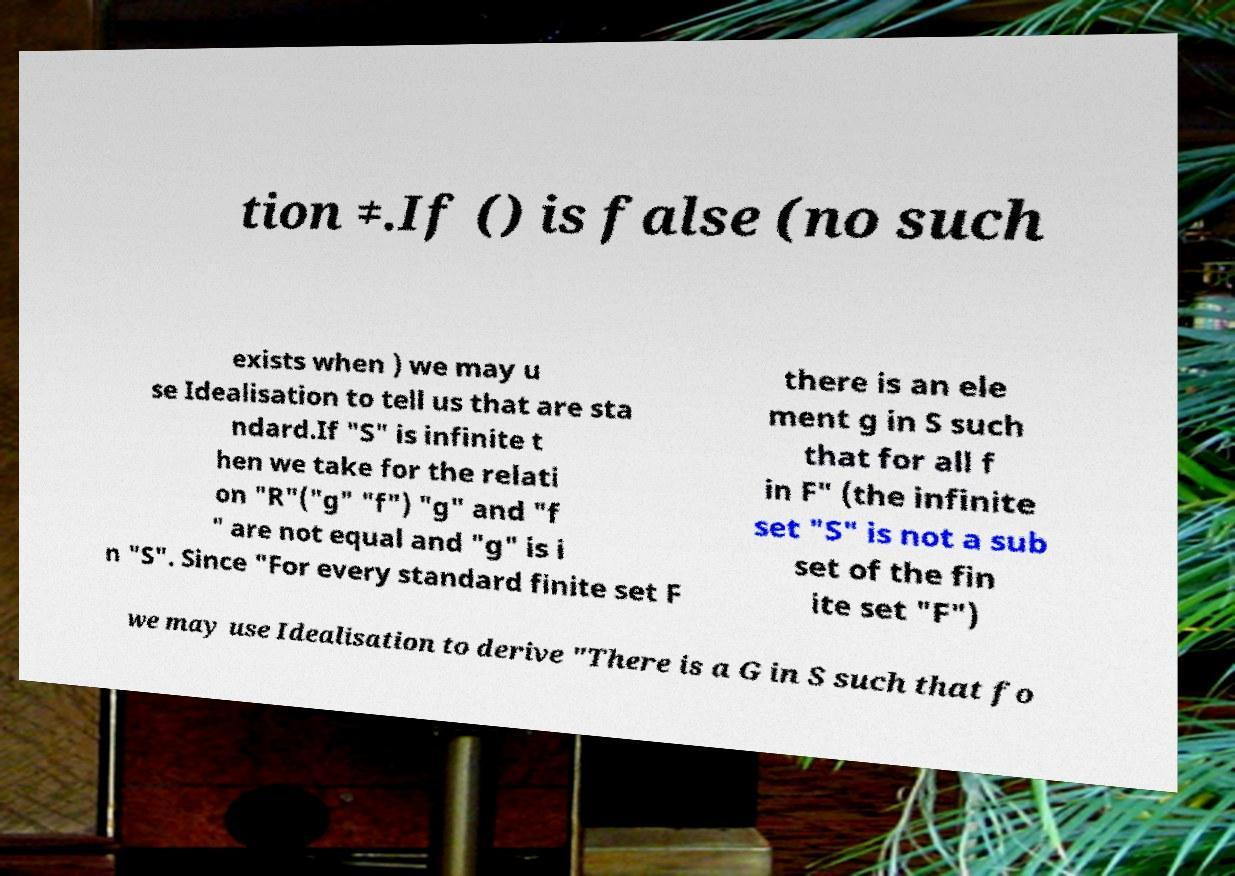Could you assist in decoding the text presented in this image and type it out clearly? tion ≠.If () is false (no such exists when ) we may u se Idealisation to tell us that are sta ndard.If "S" is infinite t hen we take for the relati on "R"("g" "f") "g" and "f " are not equal and "g" is i n "S". Since "For every standard finite set F there is an ele ment g in S such that for all f in F" (the infinite set "S" is not a sub set of the fin ite set "F") we may use Idealisation to derive "There is a G in S such that fo 